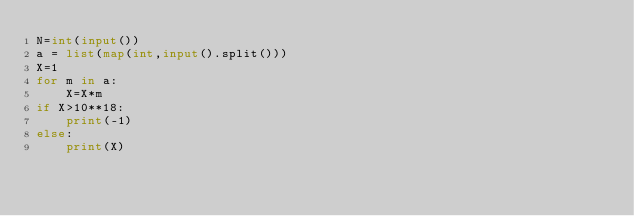Convert code to text. <code><loc_0><loc_0><loc_500><loc_500><_Python_>N=int(input())
a = list(map(int,input().split()))
X=1
for m in a:
    X=X*m
if X>10**18:
    print(-1)
else:
    print(X)</code> 